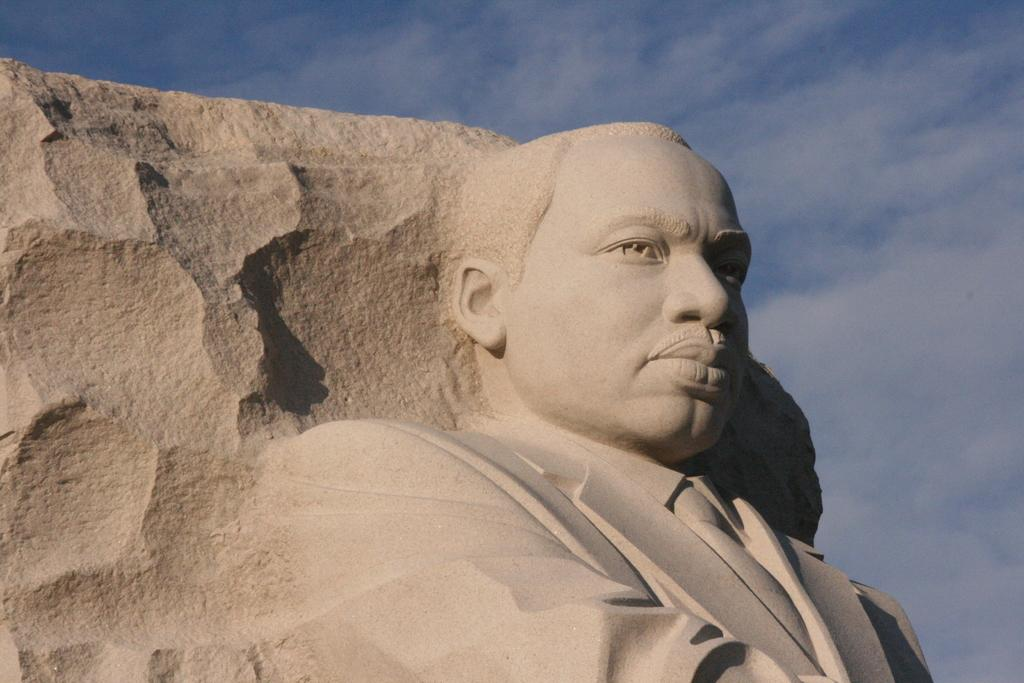What is the main subject of the image? There is a sculpture in the image. What is the sculpture depicting? The sculpture is of a person. What material is the sculpture carved on? The sculpture is carved on a rock. What type of apparel is the person in the sculpture wearing? The sculpture is not wearing any apparel, as it is a static representation of a person carved on a rock. Can you tell me how many airplanes are flying in the background of the image? There are no airplanes present in the image; it only features a sculpture carved on a rock. 